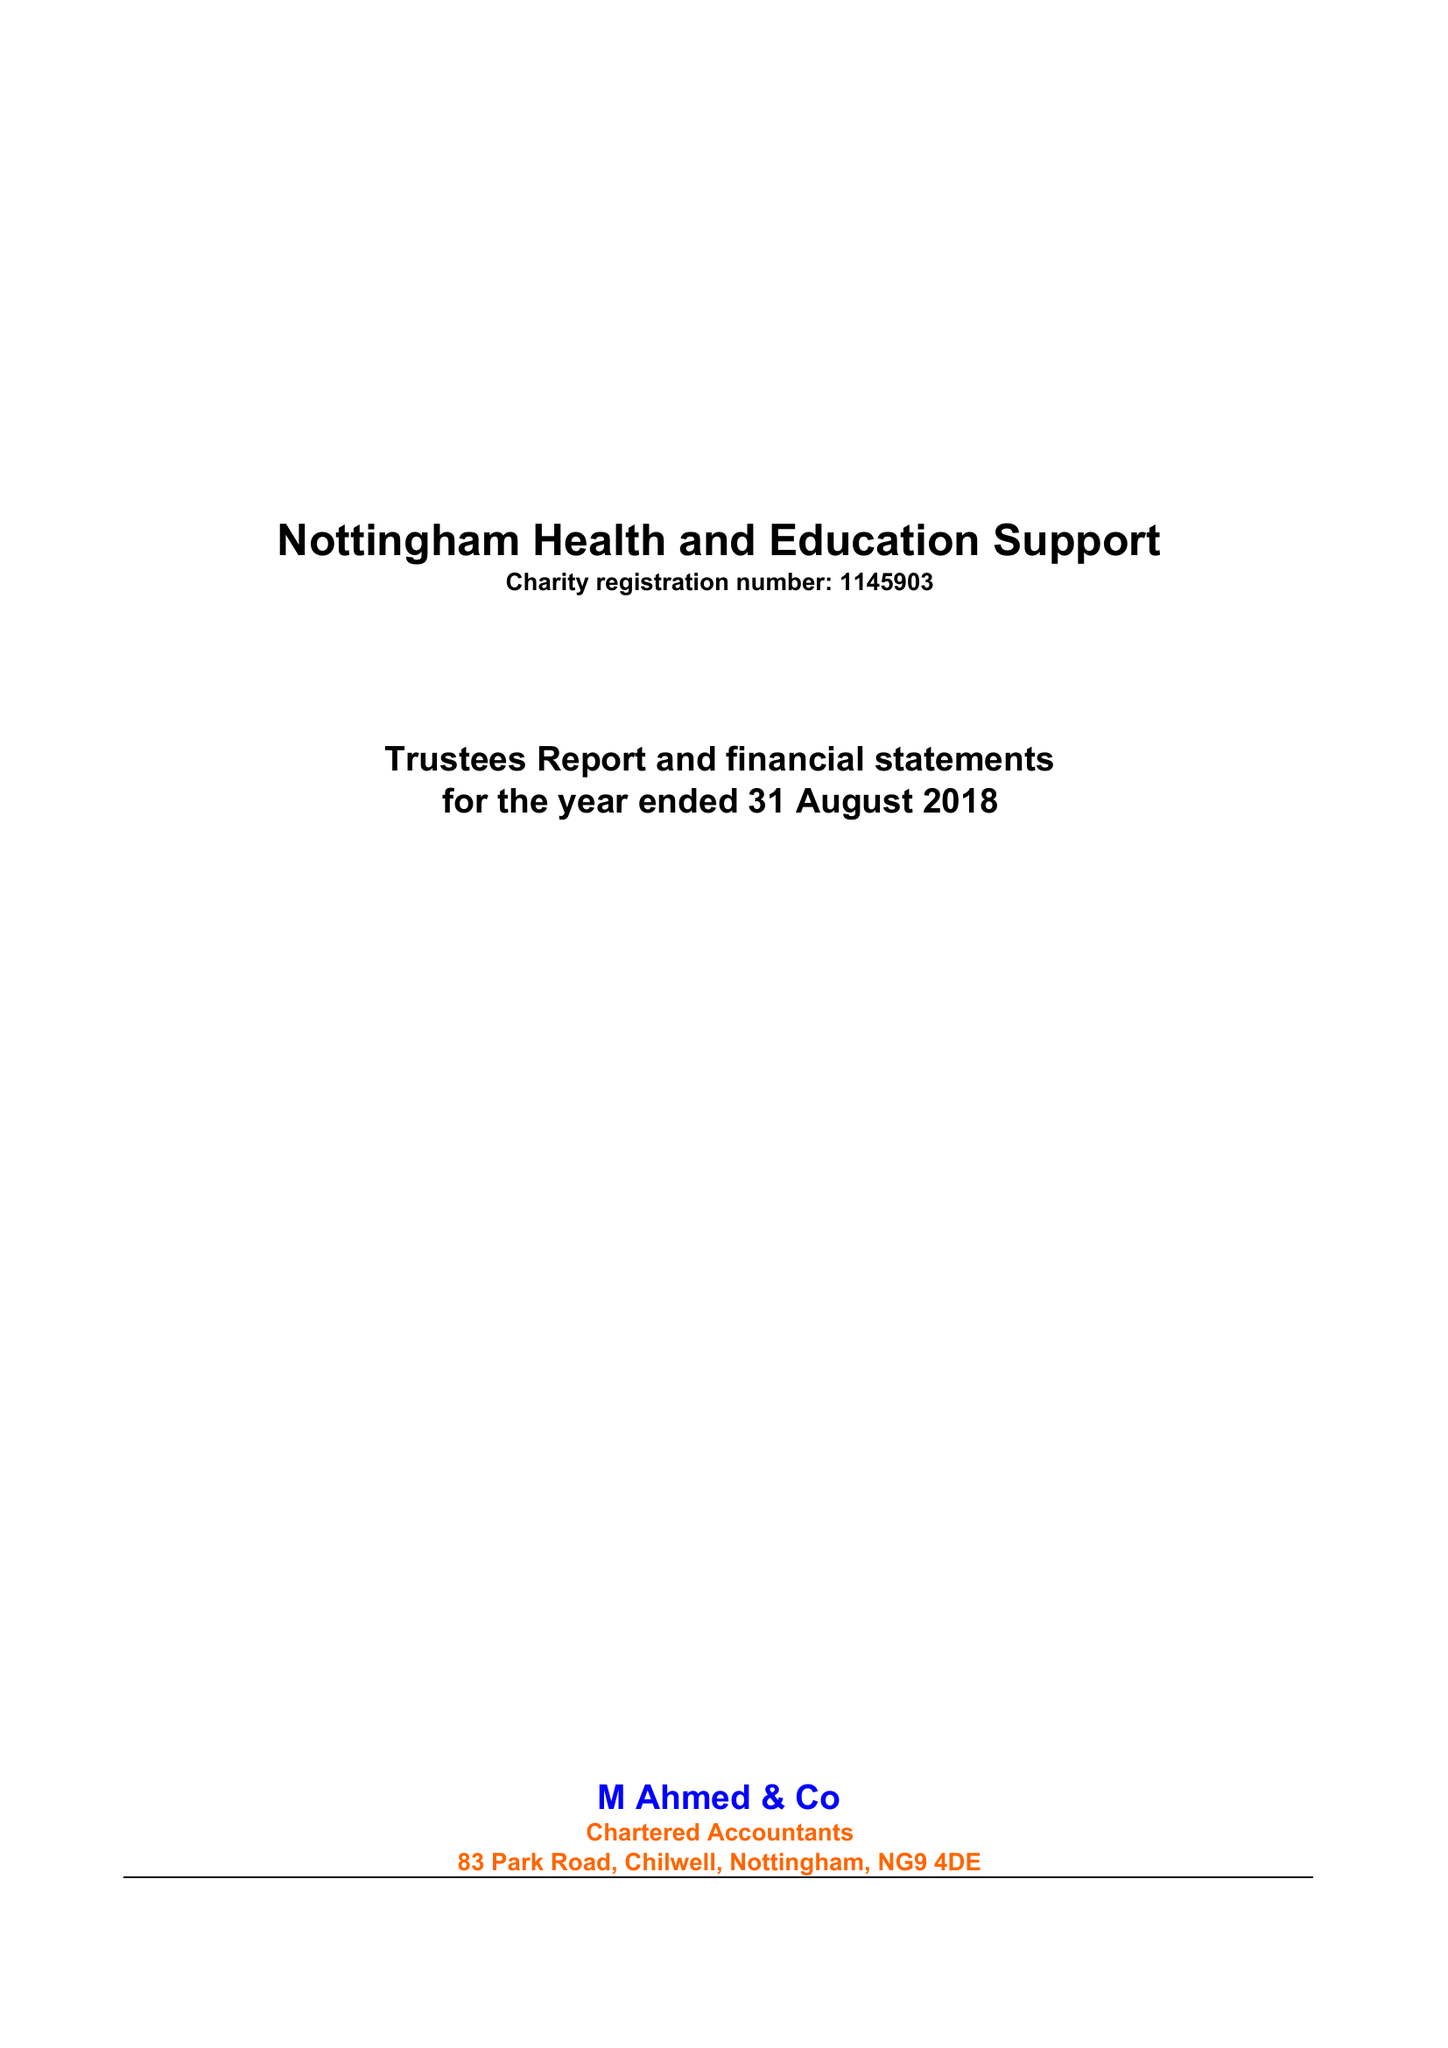What is the value for the report_date?
Answer the question using a single word or phrase. 2018-08-31 